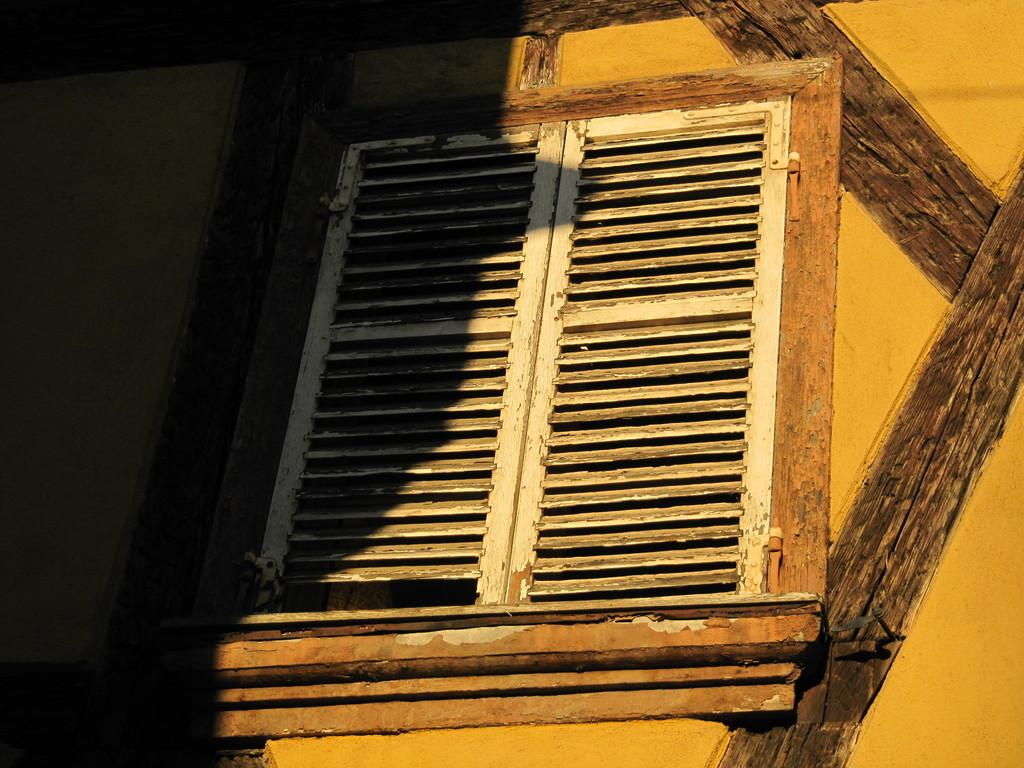What can be seen in the image that provides a view of the outside? There is a window in the image that provides a view of the outside. What objects are made of wood in the image? There are wooden sticks in the image. How many arms can be seen reaching out from the jar in the image? There is no jar or arms present in the image. What type of ray is visible in the image? There is no ray present in the image. 